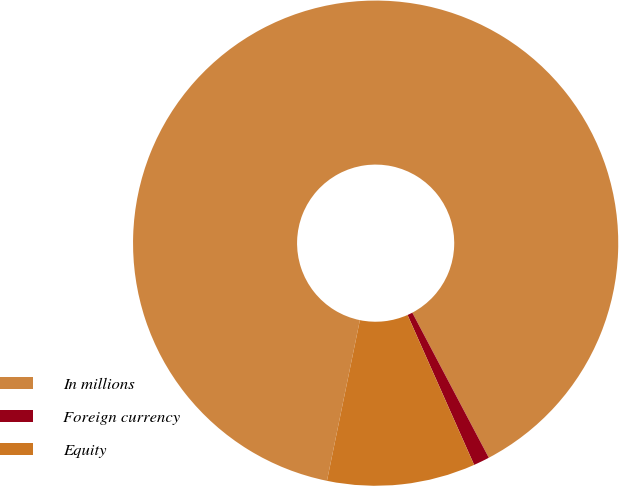Convert chart. <chart><loc_0><loc_0><loc_500><loc_500><pie_chart><fcel>In millions<fcel>Foreign currency<fcel>Equity<nl><fcel>89.06%<fcel>1.07%<fcel>9.87%<nl></chart> 